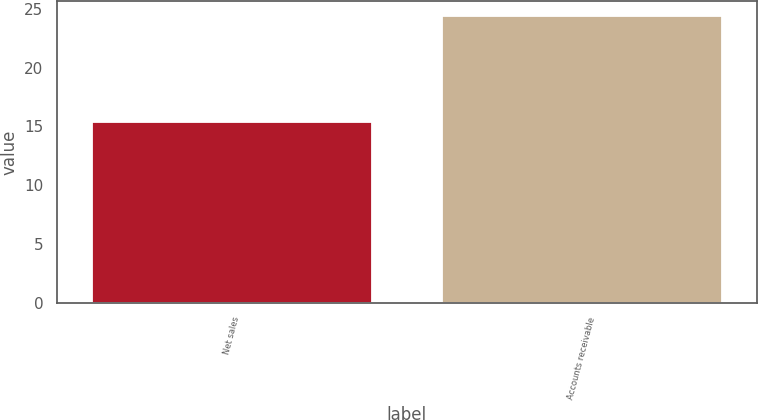Convert chart. <chart><loc_0><loc_0><loc_500><loc_500><bar_chart><fcel>Net sales<fcel>Accounts receivable<nl><fcel>15.4<fcel>24.4<nl></chart> 